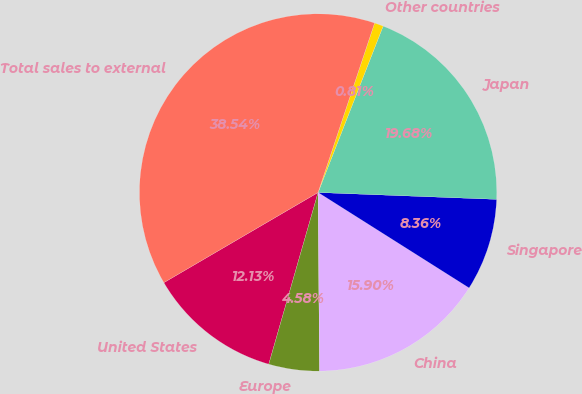Convert chart to OTSL. <chart><loc_0><loc_0><loc_500><loc_500><pie_chart><fcel>United States<fcel>Europe<fcel>China<fcel>Singapore<fcel>Japan<fcel>Other countries<fcel>Total sales to external<nl><fcel>12.13%<fcel>4.58%<fcel>15.9%<fcel>8.36%<fcel>19.68%<fcel>0.81%<fcel>38.54%<nl></chart> 